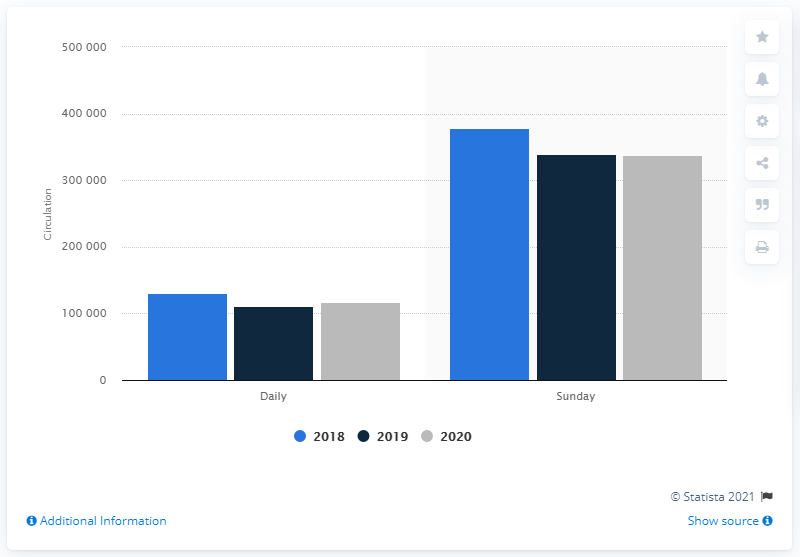Draw attention to some important aspects in this diagram. In the year 2020, the Sunday circulation of the Arizona Republic was 339,716. In 2020, the daily circulation of Arizona Republic was 116,665. 